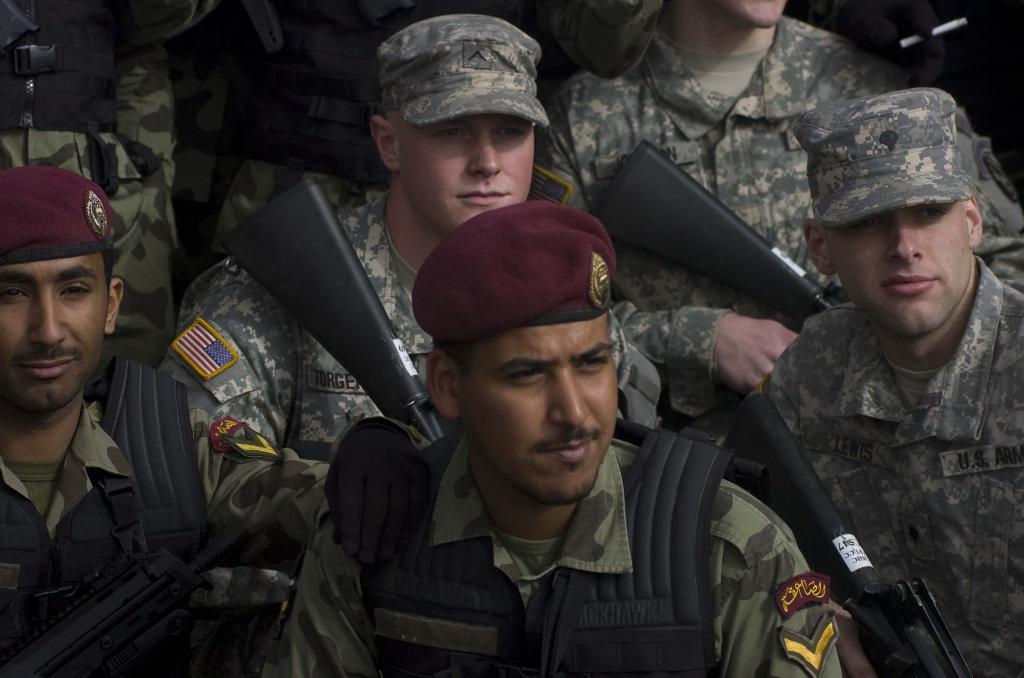What type of people are present in the image? There are military officers in the image. What are the military officers holding in the image? The military officers are holding a gun. What type of cub can be seen playing in the library in the image? There is no cub or library present in the image; it features military officers holding a gun. 